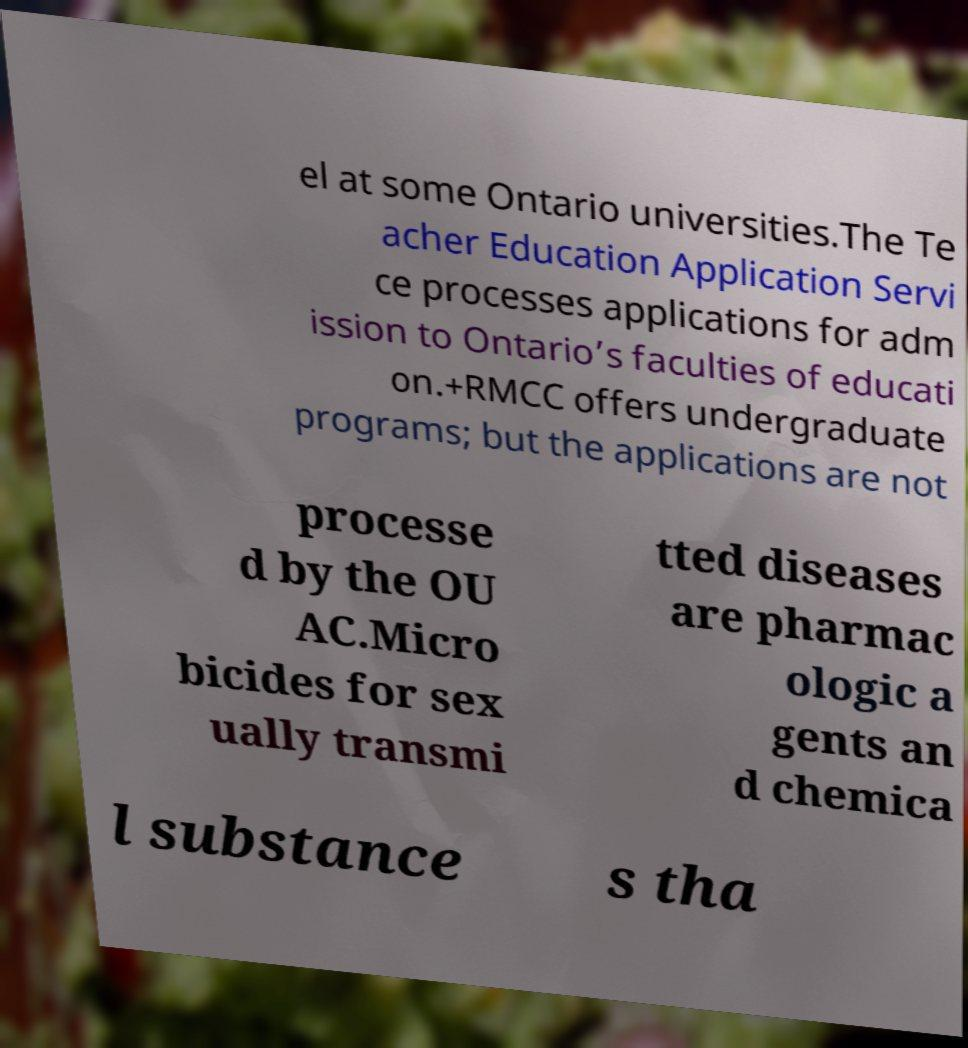There's text embedded in this image that I need extracted. Can you transcribe it verbatim? el at some Ontario universities.The Te acher Education Application Servi ce processes applications for adm ission to Ontario’s faculties of educati on.+RMCC offers undergraduate programs; but the applications are not processe d by the OU AC.Micro bicides for sex ually transmi tted diseases are pharmac ologic a gents an d chemica l substance s tha 